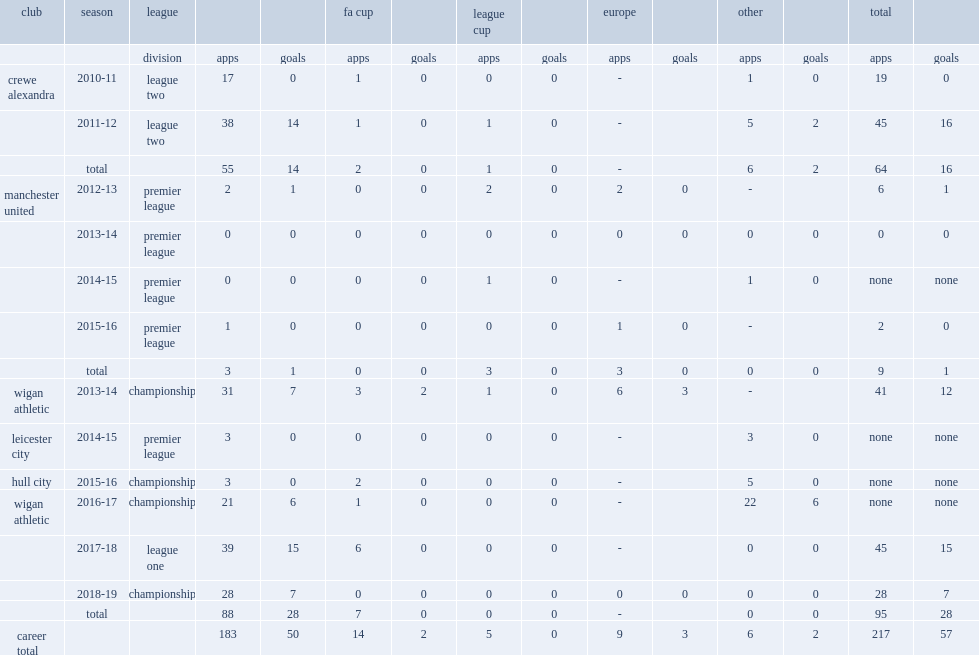Would you be able to parse every entry in this table? {'header': ['club', 'season', 'league', '', '', 'fa cup', '', 'league cup', '', 'europe', '', 'other', '', 'total', ''], 'rows': [['', '', 'division', 'apps', 'goals', 'apps', 'goals', 'apps', 'goals', 'apps', 'goals', 'apps', 'goals', 'apps', 'goals'], ['crewe alexandra', '2010-11', 'league two', '17', '0', '1', '0', '0', '0', '-', '', '1', '0', '19', '0'], ['', '2011-12', 'league two', '38', '14', '1', '0', '1', '0', '-', '', '5', '2', '45', '16'], ['', 'total', '', '55', '14', '2', '0', '1', '0', '-', '', '6', '2', '64', '16'], ['manchester united', '2012-13', 'premier league', '2', '1', '0', '0', '2', '0', '2', '0', '-', '', '6', '1'], ['', '2013-14', 'premier league', '0', '0', '0', '0', '0', '0', '0', '0', '0', '0', '0', '0'], ['', '2014-15', 'premier league', '0', '0', '0', '0', '1', '0', '-', '', '1', '0', 'none', 'none'], ['', '2015-16', 'premier league', '1', '0', '0', '0', '0', '0', '1', '0', '-', '', '2', '0'], ['', 'total', '', '3', '1', '0', '0', '3', '0', '3', '0', '0', '0', '9', '1'], ['wigan athletic', '2013-14', 'championship', '31', '7', '3', '2', '1', '0', '6', '3', '-', '', '41', '12'], ['leicester city', '2014-15', 'premier league', '3', '0', '0', '0', '0', '0', '-', '', '3', '0', 'none', 'none'], ['hull city', '2015-16', 'championship', '3', '0', '2', '0', '0', '0', '-', '', '5', '0', 'none', 'none'], ['wigan athletic', '2016-17', 'championship', '21', '6', '1', '0', '0', '0', '-', '', '22', '6', 'none', 'none'], ['', '2017-18', 'league one', '39', '15', '6', '0', '0', '0', '-', '', '0', '0', '45', '15'], ['', '2018-19', 'championship', '28', '7', '0', '0', '0', '0', '0', '0', '0', '0', '28', '7'], ['', 'total', '', '88', '28', '7', '0', '0', '0', '-', '', '0', '0', '95', '28'], ['career total', '', '', '183', '50', '14', '2', '5', '0', '9', '3', '6', '2', '217', '57']]} In 2017-18, which league did powell play with wigan athletic in? League one. 